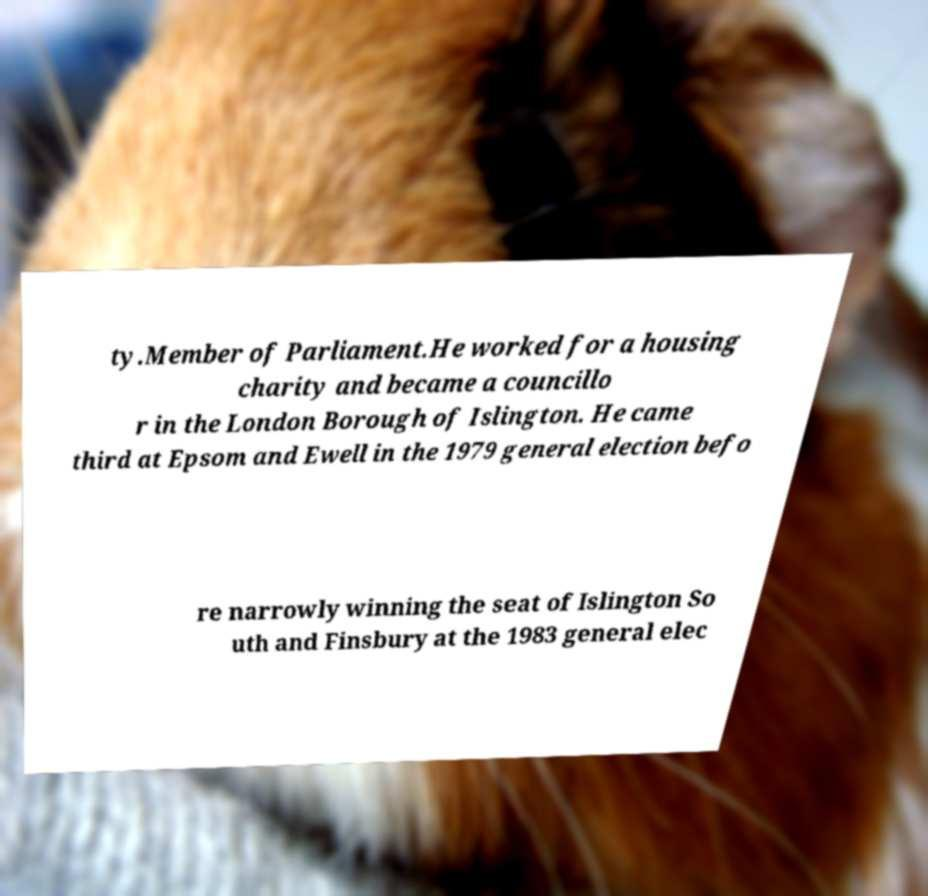I need the written content from this picture converted into text. Can you do that? ty.Member of Parliament.He worked for a housing charity and became a councillo r in the London Borough of Islington. He came third at Epsom and Ewell in the 1979 general election befo re narrowly winning the seat of Islington So uth and Finsbury at the 1983 general elec 